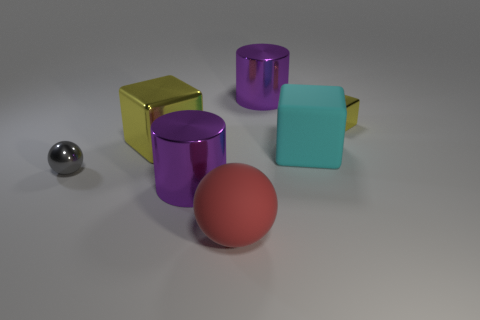Would you say there's any underlying theme or message conveyed by the arrangement of these objects? Without additional context, it's open to interpretation; however, one might say that the arrangement of the objects conveys a sense of balance and harmony amongst diversity. The differing sizes, shapes, and colors of the objects, along with their varied textures, suggest a deliberate composition that celebrates variety. The way they are positioned could evoke thoughts on individuality, uniqueness, and how varying elements can coexist within the same space. 